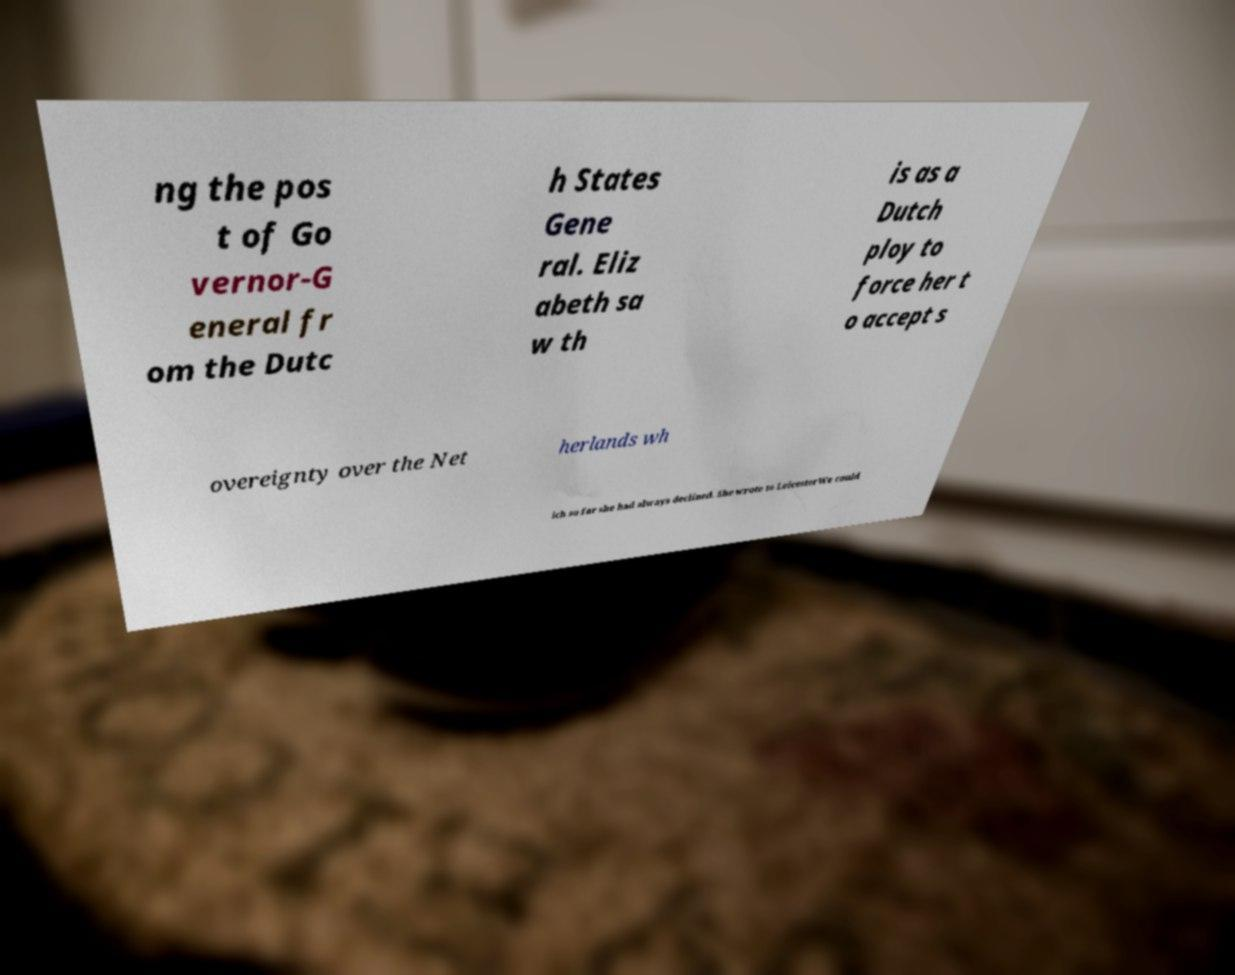For documentation purposes, I need the text within this image transcribed. Could you provide that? ng the pos t of Go vernor-G eneral fr om the Dutc h States Gene ral. Eliz abeth sa w th is as a Dutch ploy to force her t o accept s overeignty over the Net herlands wh ich so far she had always declined. She wrote to LeicesterWe could 